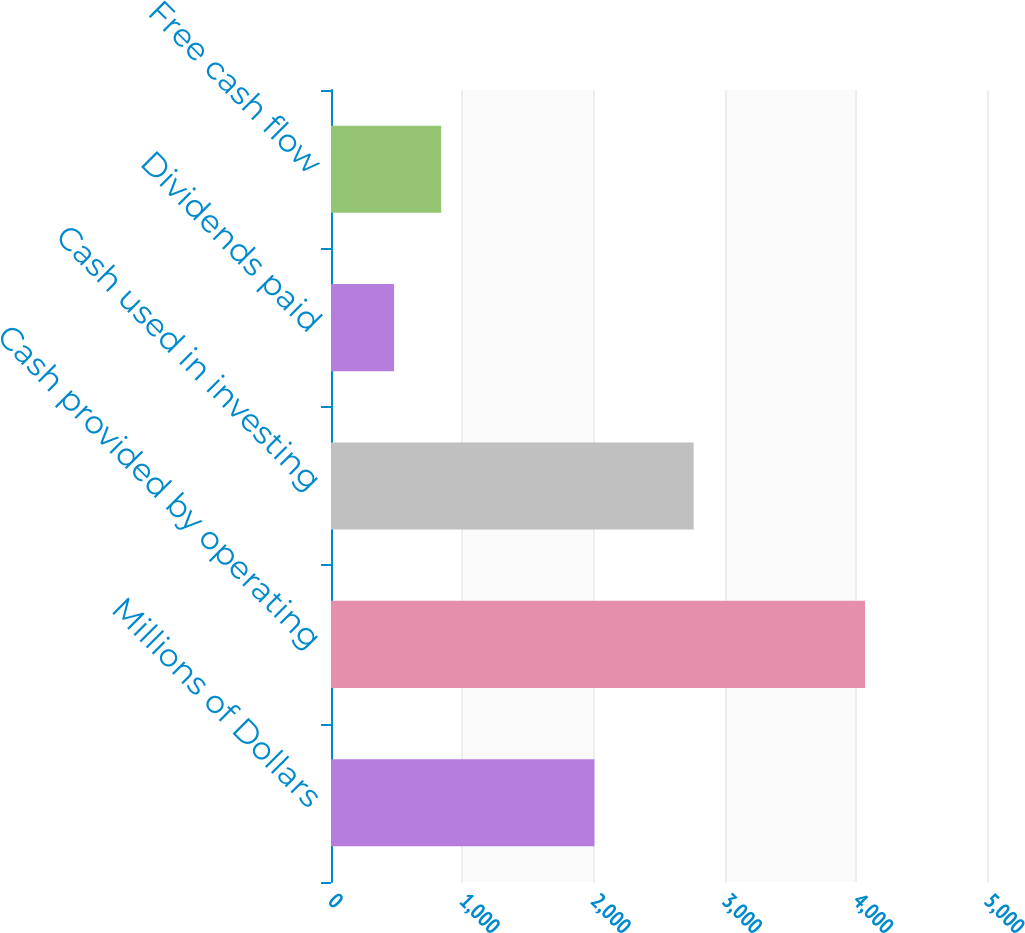Convert chart to OTSL. <chart><loc_0><loc_0><loc_500><loc_500><bar_chart><fcel>Millions of Dollars<fcel>Cash provided by operating<fcel>Cash used in investing<fcel>Dividends paid<fcel>Free cash flow<nl><fcel>2008<fcel>4070<fcel>2764<fcel>481<fcel>839.9<nl></chart> 